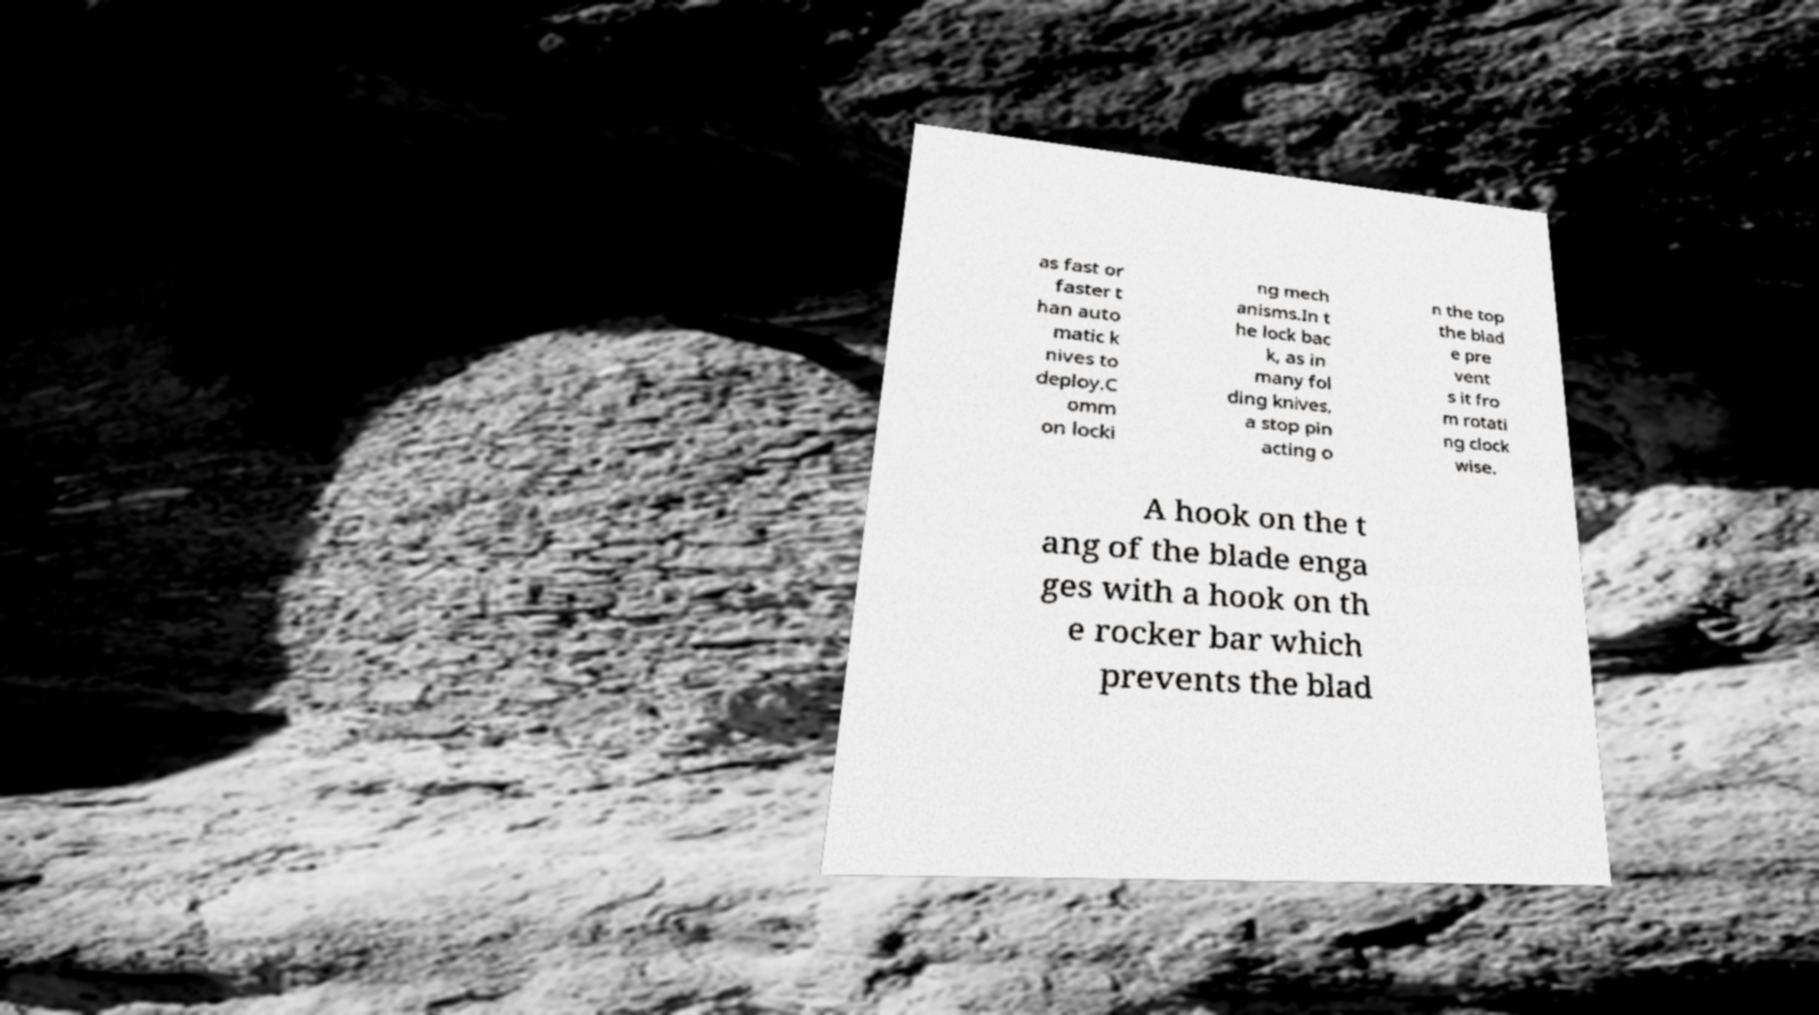Could you assist in decoding the text presented in this image and type it out clearly? as fast or faster t han auto matic k nives to deploy.C omm on locki ng mech anisms.In t he lock bac k, as in many fol ding knives, a stop pin acting o n the top the blad e pre vent s it fro m rotati ng clock wise. A hook on the t ang of the blade enga ges with a hook on th e rocker bar which prevents the blad 